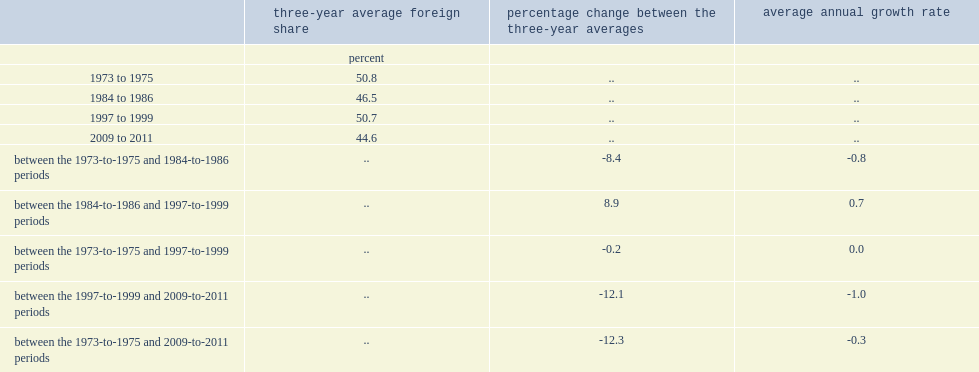What was the average foreign share during the years 1973 to 1975 and during the years 2009 to 2011? 50.8 44.6. What was the average annual growth rate between the 1973-to-1975 and 2009-to-2011 periods? -0.3. What was the percentage change between the 1973-to-1975 and 1984-to-1986 periods? -8.4. What was the average foreign share in 1997 to 1999? 50.7. 